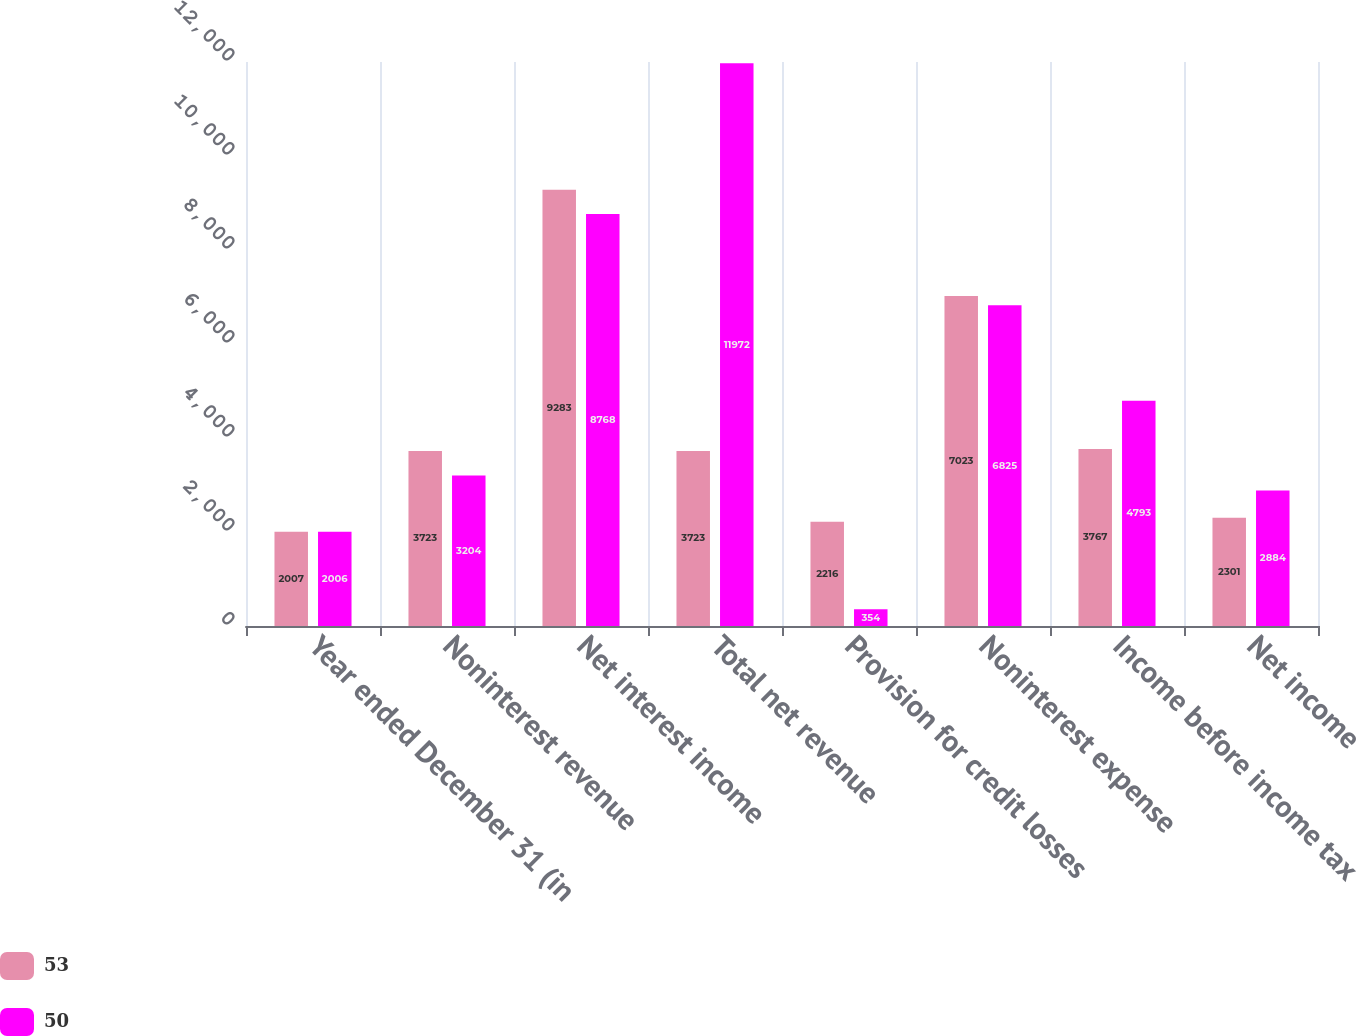Convert chart to OTSL. <chart><loc_0><loc_0><loc_500><loc_500><stacked_bar_chart><ecel><fcel>Year ended December 31 (in<fcel>Noninterest revenue<fcel>Net interest income<fcel>Total net revenue<fcel>Provision for credit losses<fcel>Noninterest expense<fcel>Income before income tax<fcel>Net income<nl><fcel>53<fcel>2007<fcel>3723<fcel>9283<fcel>3723<fcel>2216<fcel>7023<fcel>3767<fcel>2301<nl><fcel>50<fcel>2006<fcel>3204<fcel>8768<fcel>11972<fcel>354<fcel>6825<fcel>4793<fcel>2884<nl></chart> 